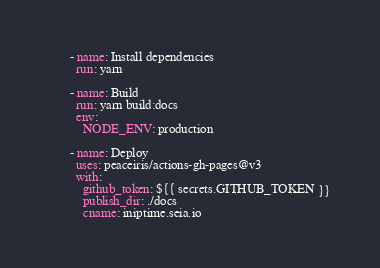<code> <loc_0><loc_0><loc_500><loc_500><_YAML_>
      - name: Install dependencies
        run: yarn

      - name: Build
        run: yarn build:docs
        env:
          NODE_ENV: production

      - name: Deploy
        uses: peaceiris/actions-gh-pages@v3
        with:
          github_token: ${{ secrets.GITHUB_TOKEN }}
          publish_dir: ./docs
          cname: iniptime.seia.io
</code> 